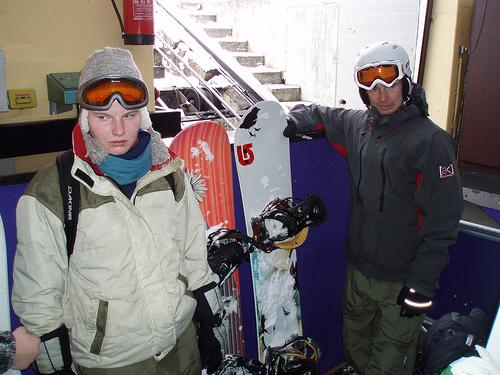List the colors of the snowboards and their distinguishing characteristics, if any. There are two snowboards: one white with a red graphic, and the other a pink-striped orange board. They have different colors and designs, making them easy to tell apart. What color are the man's jacket, pants, and helmet, and what is he wearing on his face? The man is wearing a dark gray jacket with a red under area, green ski pants, a white helmet with an orange X, and orange snow goggles on his head. What is the notable object attached to the wall, and what is its purpose? A red fire extinguisher with a black bottom is mounted on the wall, which serves to put out fires in case of an emergency. In the context of this image, what purpose do the tan lit stairs serve, and where are they located? The tan lit stairs are an underground stairwell full of snow, possibly providing access to another area. They are located at the top-left portion of the image with a width of 102 pixels and a height of 102 pixels. Describe the man's outfit, including his jacket, pants, helmet, and ski goggles. The man is dressed for cold weather, wearing a gray jacket, green ski pants, a white helmet with an orange X, and orange snow goggles. How are the snowboards positioned in relation to the snowboarders, and what do the bindings look like? The snowboards are standing in the snow nearby the snowboarders. The snowboard bindings are visible and distinct, with a width of 79 pixels and a height of 79 pixels. Explain the significance of snow goggles and why they are important for snowboarders. Sunsnow goggles provide essential eye protection for snowboarders, shielding them from snow, wind, and harmful UV rays that could damage their vision. Provide a brief description of the person who is wearing a tan coat, blue scarf, and snow goggles. The person is dressed for cold weather in a tan coat, a blue scarf wrapped around their neck, and sun snow goggles as important eye protection. What snowboarding accessories can be seen in the image, and what purpose do they serve? Some of the snowboarding accessories include helmets for head protection, ski goggles for eye protection, gloves to keep hands warm, and bindings to secure the feet to the snowboard. What does the scene mostly illustrate, and what are the people engaged in? The scene shows two snowboarders dressed for cold weather, with their snowboards standing in the snow, and various accessories like helmets, gloves, and goggles. 